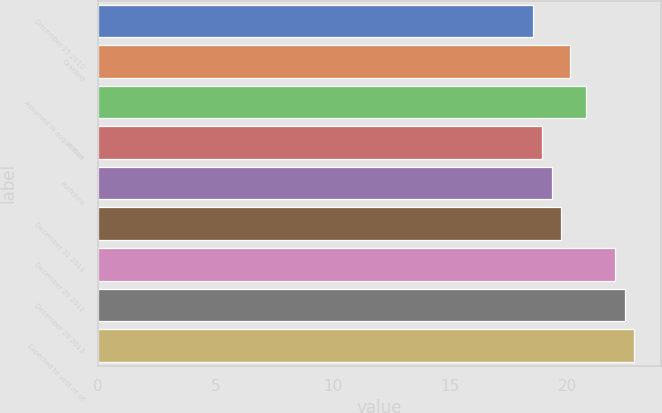Convert chart. <chart><loc_0><loc_0><loc_500><loc_500><bar_chart><fcel>December 25 2010<fcel>Granted<fcel>Assumed in acquisition<fcel>Vested<fcel>Forfeited<fcel>December 31 2011<fcel>December 29 2012<fcel>December 28 2013<fcel>Expected to vest as of<nl><fcel>18.56<fcel>20.12<fcel>20.8<fcel>18.95<fcel>19.34<fcel>19.73<fcel>22.03<fcel>22.47<fcel>22.86<nl></chart> 